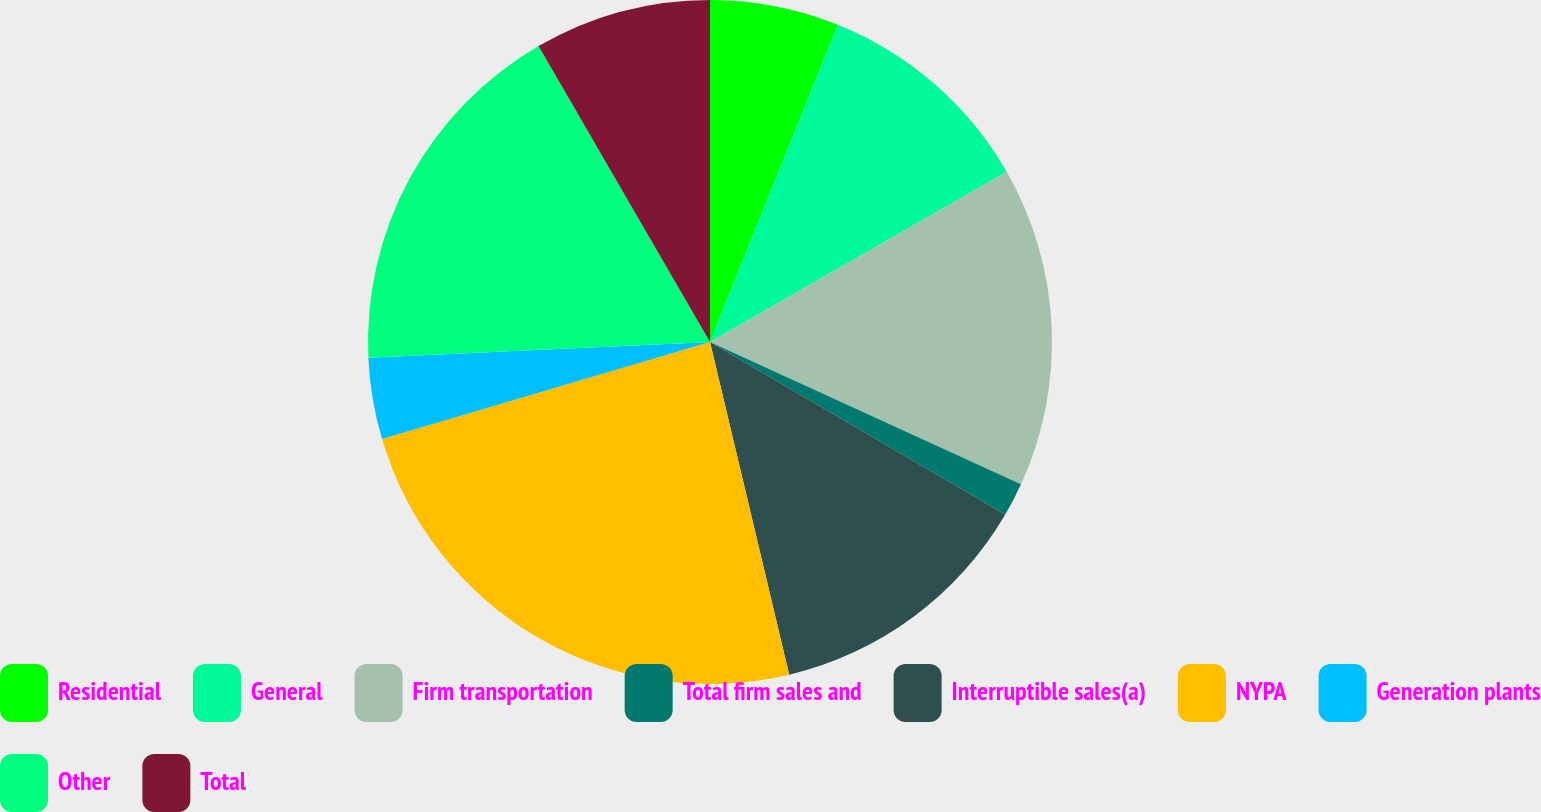<chart> <loc_0><loc_0><loc_500><loc_500><pie_chart><fcel>Residential<fcel>General<fcel>Firm transportation<fcel>Total firm sales and<fcel>Interruptible sales(a)<fcel>NYPA<fcel>Generation plants<fcel>Other<fcel>Total<nl><fcel>6.1%<fcel>10.61%<fcel>15.12%<fcel>1.59%<fcel>12.86%<fcel>24.14%<fcel>3.85%<fcel>17.37%<fcel>8.36%<nl></chart> 